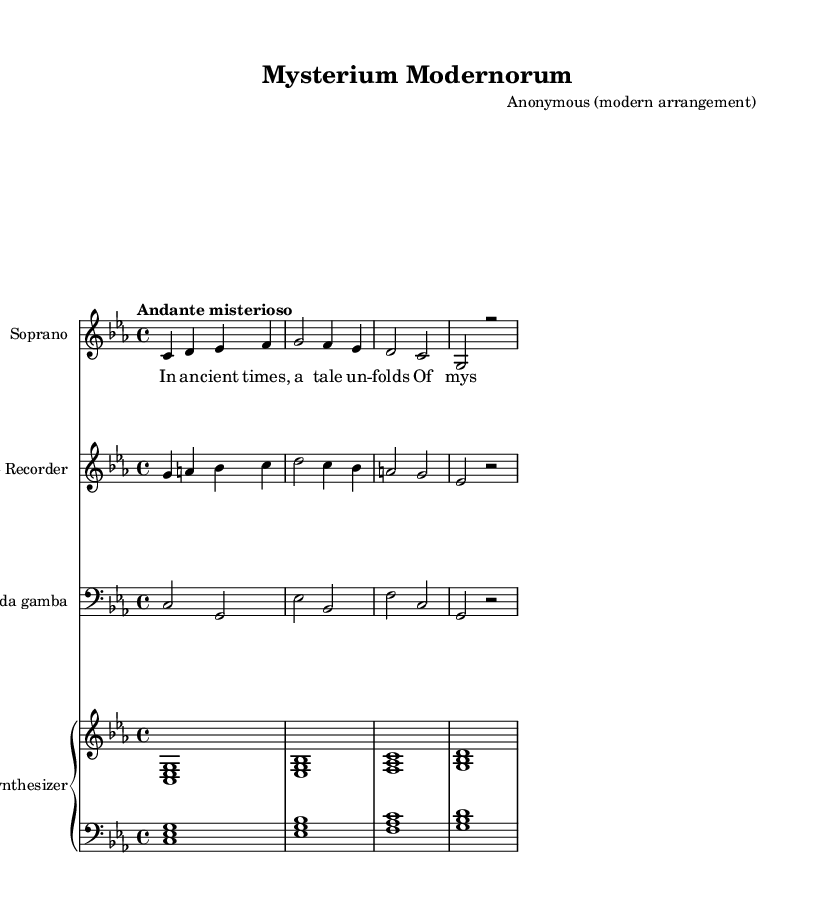What is the key signature of this music? The key signature is C minor, indicated by three flats on the staff, which denote the pitches in the scale.
Answer: C minor What is the time signature of this music? The time signature is 4/4, which is shown at the beginning of the score, indicating there are four beats in each measure.
Answer: 4/4 What is the tempo marking for this piece? The tempo marking is "Andante misterioso," which gives a specific feel for the piece and suggests a moderately slow and mysterious pace.
Answer: Andante misterioso How many instruments are featured in this score? There are four instruments indicated in the score: Soprano, Alto Recorder, Viola da Gamba, and Synthesizer.
Answer: Four What is the overall theme of the lyrics in this piece? The lyrics speak of mystery and grace, reflecting a timeless tale that unfolds, which is typical for religious or spiritual themes in medieval mystery play music.
Answer: Mystery and grace What is the role of the synthesizer in the context of the piece? The synthesizer provides a more modern sound texture and harmonization, which contrasts with the traditional acoustic instruments, enriching the overall interpretation.
Answer: Harmonization What does the repeated phrase "Mys — te — ri — um" signify in the lyrics? The repeated phrase "Mys — te — ri — um" emphasizes the central theme of the piece, highlighting the importance of mystery in the narrative.
Answer: Central theme 